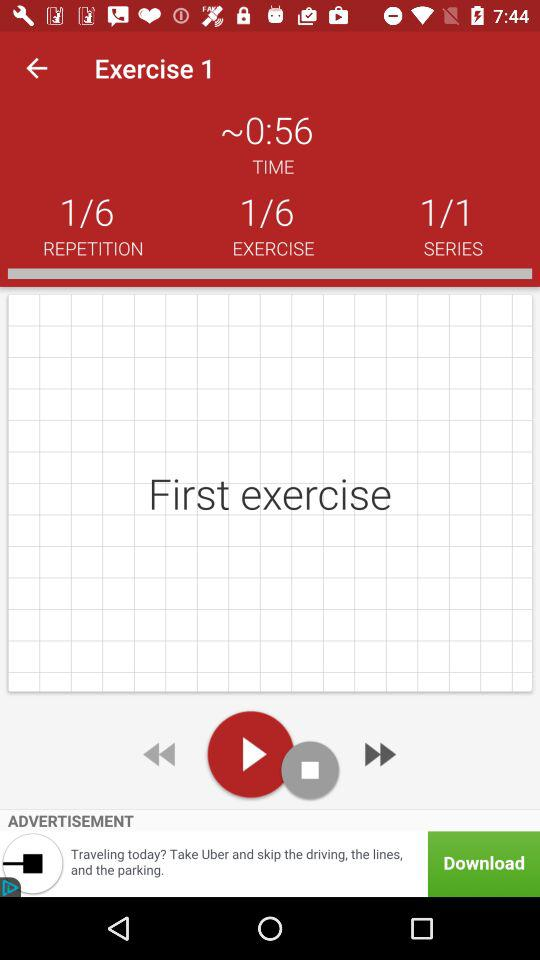What is the total number of exercises? The total number of exercises is 6. 